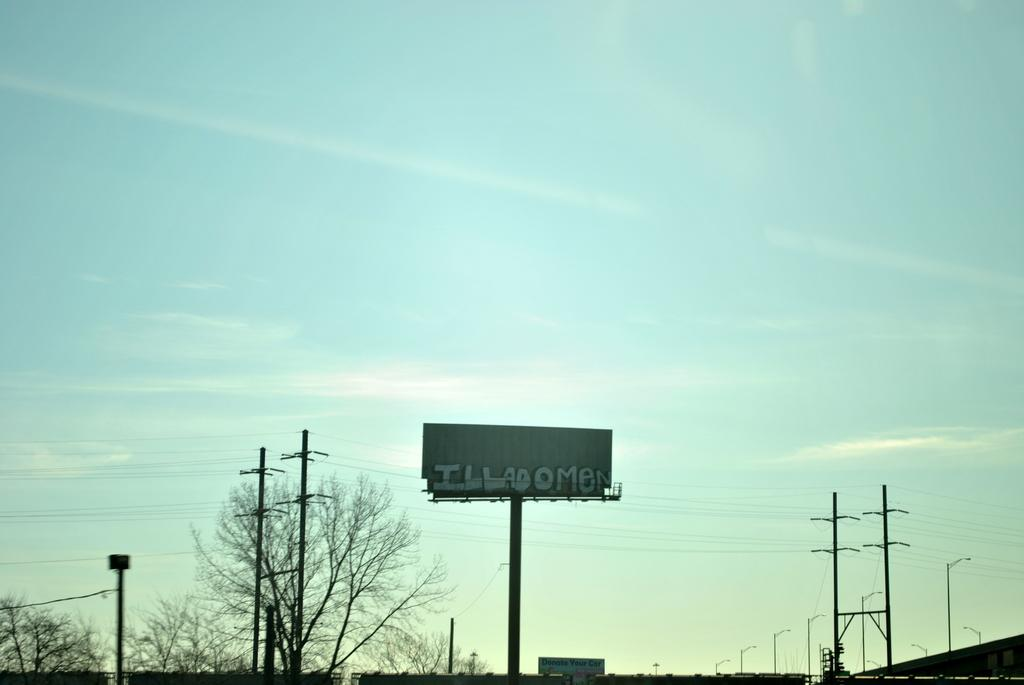<image>
Render a clear and concise summary of the photo. A billboard with ILLADOMEN written on it on a sunny day 